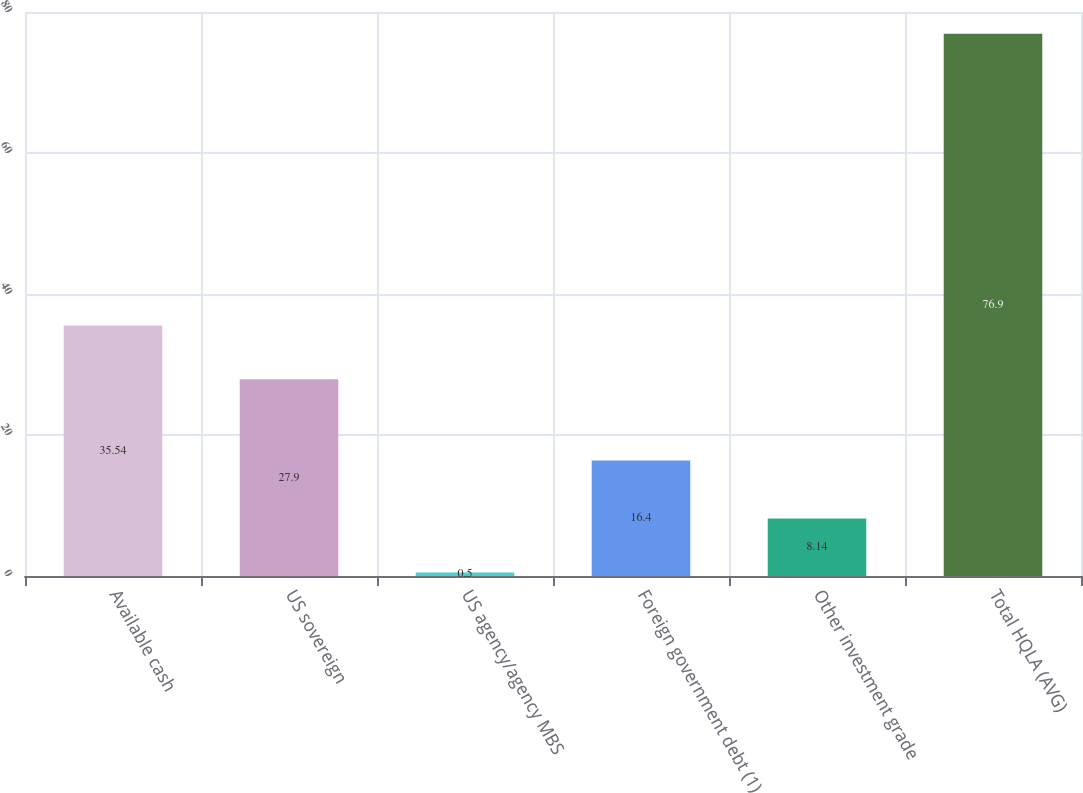<chart> <loc_0><loc_0><loc_500><loc_500><bar_chart><fcel>Available cash<fcel>US sovereign<fcel>US agency/agency MBS<fcel>Foreign government debt (1)<fcel>Other investment grade<fcel>Total HQLA (AVG)<nl><fcel>35.54<fcel>27.9<fcel>0.5<fcel>16.4<fcel>8.14<fcel>76.9<nl></chart> 